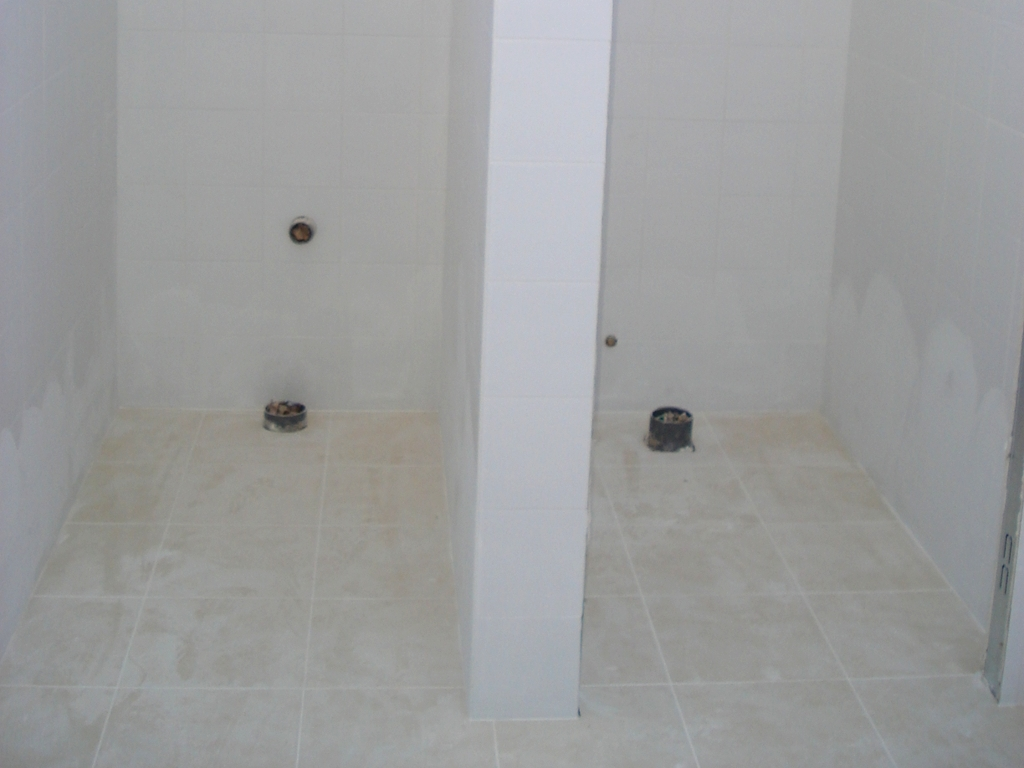Could this be an example of minimalist design in architecture? Yes, the image could represent minimalist design principles, which are characterized by simplicity, clean lines, uncluttered spaces, and a monochromatic color scheme. The focus on functionality and the absence of non-essential forms, features, and concepts are key elements of minimalism which are present in this space. 